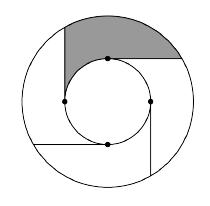How is the shaded region affected if the number of tangent rays doubles? Doubling the number of tangent rays to eight would split each of the current segments into two smaller, equal segments. This increases the resolution of the regions, but fundamentally, it would maintain the proportion of the shaded to unshaded regions since the alternation pattern of shaded and unshaded areas would also double. Consequently, doubling the rays retains the shaded area still at $12\pi$, as the new segments would divide existing areas more finely but keep the overall pattern. 